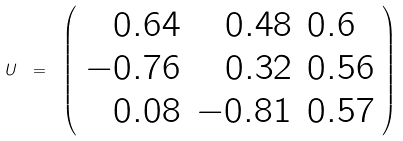Convert formula to latex. <formula><loc_0><loc_0><loc_500><loc_500>U \ = \ \left ( \begin{array} { r r l } { 0 . 6 4 } & { 0 . 4 8 } & { 0 . 6 } \\ { - 0 . 7 6 } & { 0 . 3 2 } & { 0 . 5 6 } \\ { 0 . 0 8 } & { - 0 . 8 1 } & { 0 . 5 7 } \end{array} \right )</formula> 